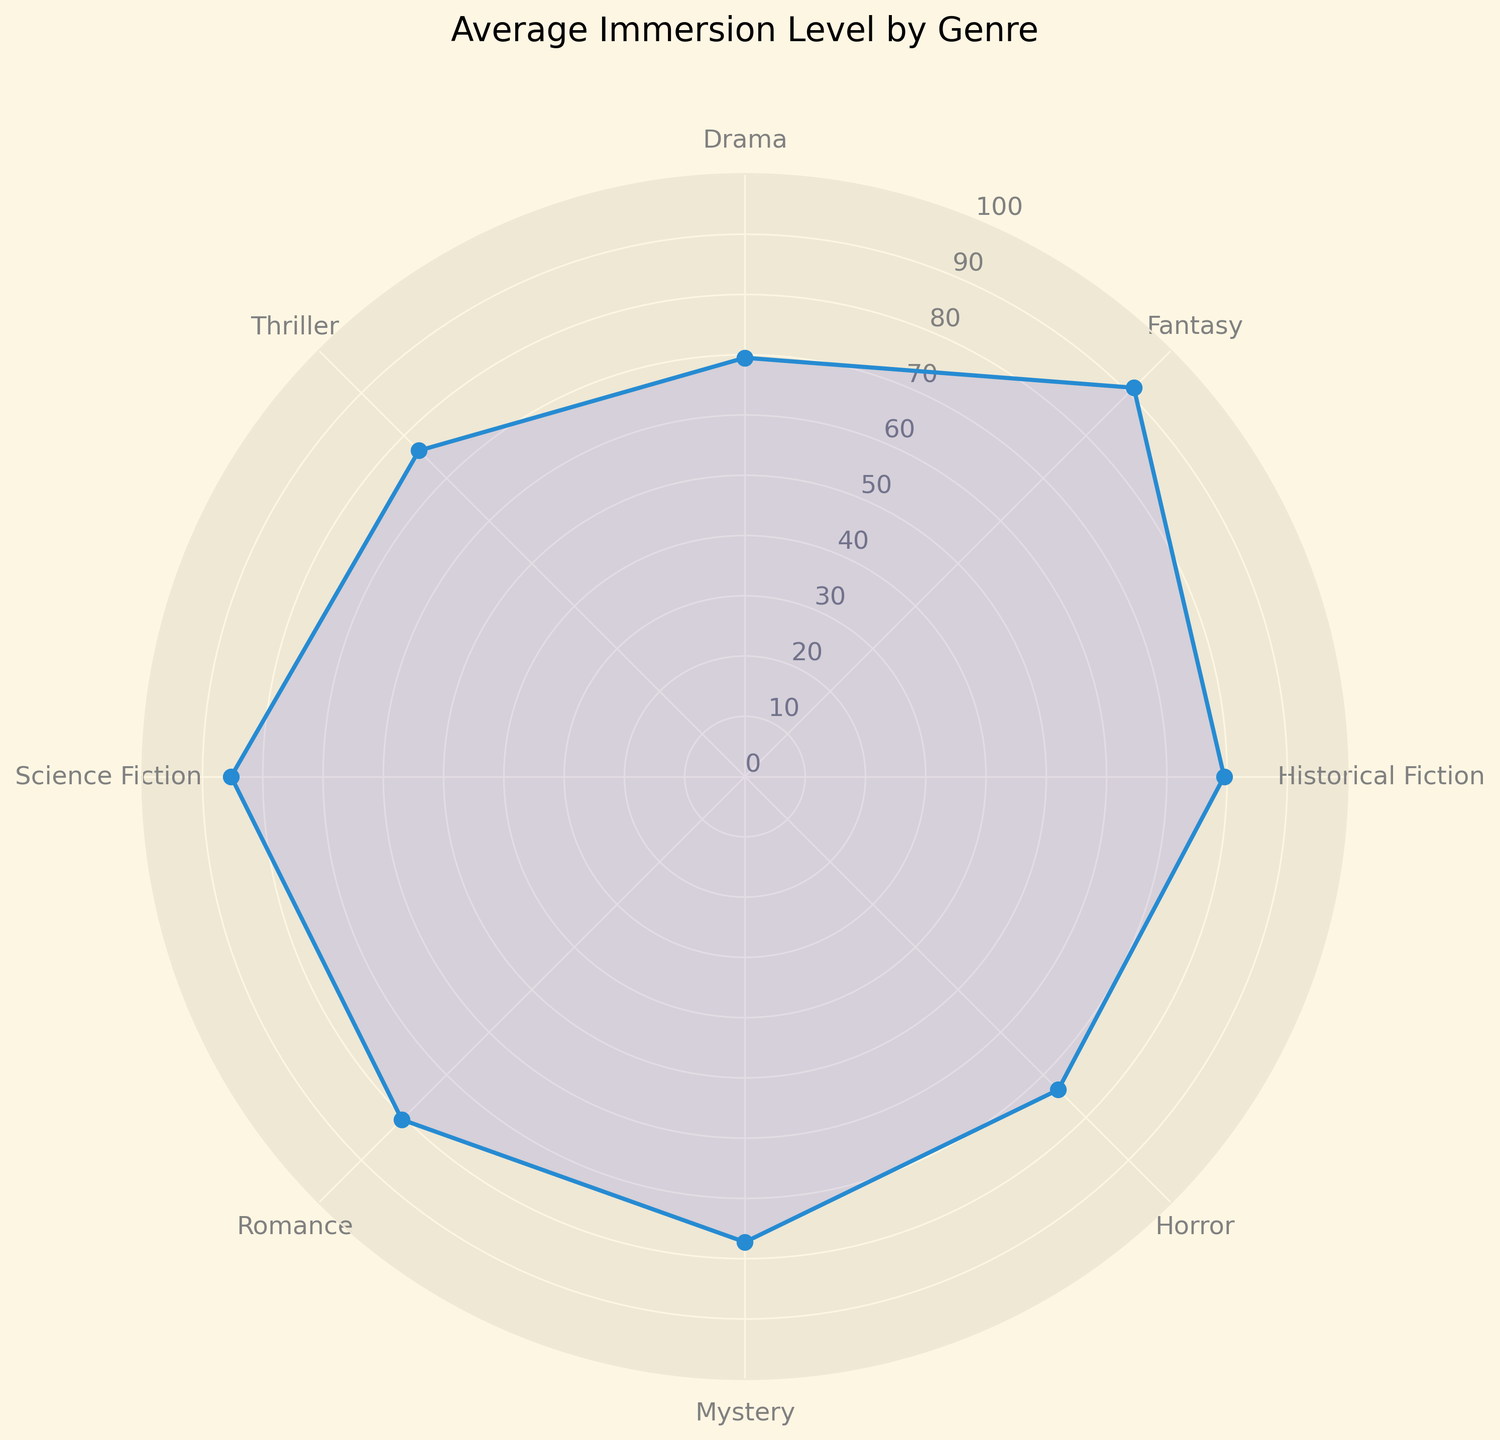What's the average immersion level for Fantasy genre? By looking at the figure, we identify the category labeled "Fantasy" and note the corresponding immersion level on the radial axis. The average immersion level for Fantasy is derived directly from the figure's values.
Answer: 91.25 Which genre has the lowest average immersion level? Compare the immersion levels of all genres shown in the figure to find the one with the smallest value. The genre with the lowest immersion level will be at the shortest radial distance from the center.
Answer: Drama Which genre has a higher average immersion level, Horror or Mystery? Locate the points on the chart corresponding to Horror and Mystery, and compare their immersion levels. Identify which radial point is further from the center.
Answer: Mystery What is the difference between the highest and lowest average immersion levels? Identify the genre with the highest and the genre with the lowest average immersion levels and calculate the difference between these two values.
Answer: 23.25 How does the average immersion level of Historical Fiction compare to Romance? Find the average immersion levels of both Historical Fiction and Romance on the figure, and directly compare their values by observing the radial distances from the center.
Answer: Historical Fiction is slightly lower What is the average immersion level across all genres? Sum the mean immersion levels of all genres as illustrated on the chart, then divide by the number of genres.
Answer: 79.4 Is the average immersion level of Science Fiction greater than Thriller? Check the immersion levels indicated by the plot for both Science Fiction and Thriller, and determine if the value for Science Fiction is greater.
Answer: Yes Which genres have an average immersion level greater than 80? Observe the immersion levels for each genre on the chart and list those whose values are above the 80 mark on the radial axis.
Answer: Fantasy, Science Fiction, Romance, Historical Fiction Approximately how much higher is the average immersion level of Fantasy compared to Drama? Find the average immersion levels for Fantasy and Drama, then subtract the value for Drama from Fantasy's value.
Answer: 22.25 Which genres have similar average immersion levels? Look for genres with similar radial distances from the center and group them accordingly.
Answer: Romance and Historical Fiction 